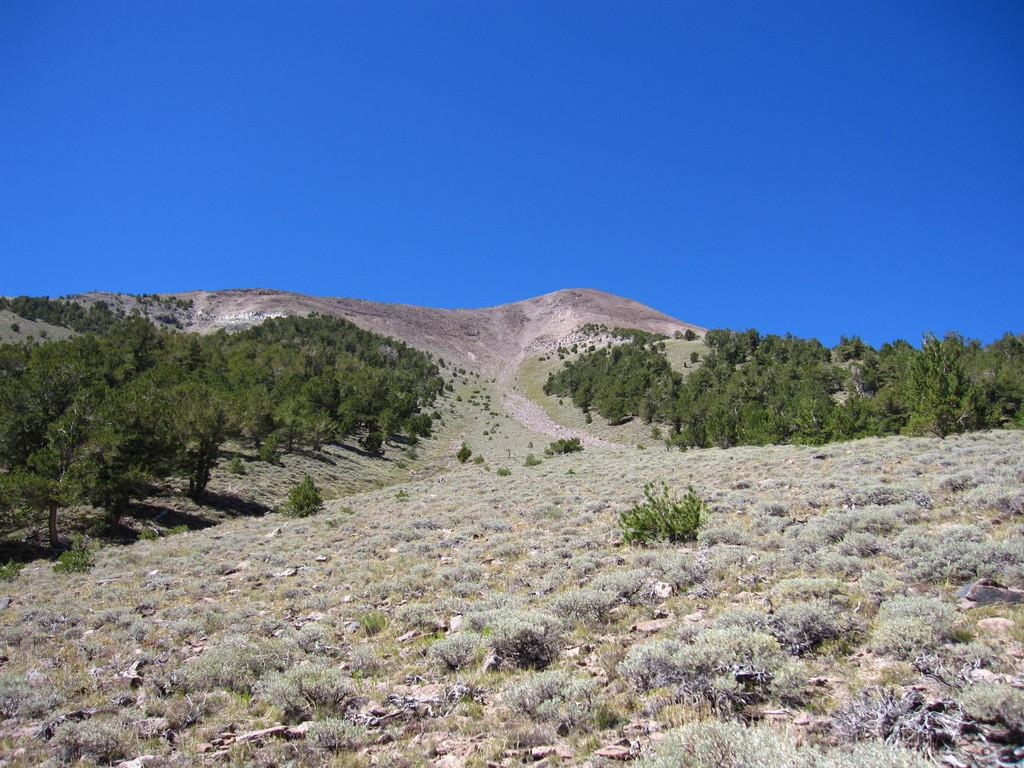Where was the image taken? The image was clicked outside. What type of vegetation can be seen on the ground in the image? There are small plants and grass on the ground in the image. What can be seen in the middle of the image? There are trees in the middle of the image. What is visible at the top of the image? The sky is visible at the top of the image. What color is the sky in the image? The sky is blue in color. How many ants are crawling on the trees in the image? There are no ants visible in the image; it only shows trees, grass, and the sky. Can you tell me what type of lawyer is standing near the trees in the image? There are no lawyers present in the image; it only features trees, grass, and the sky. 